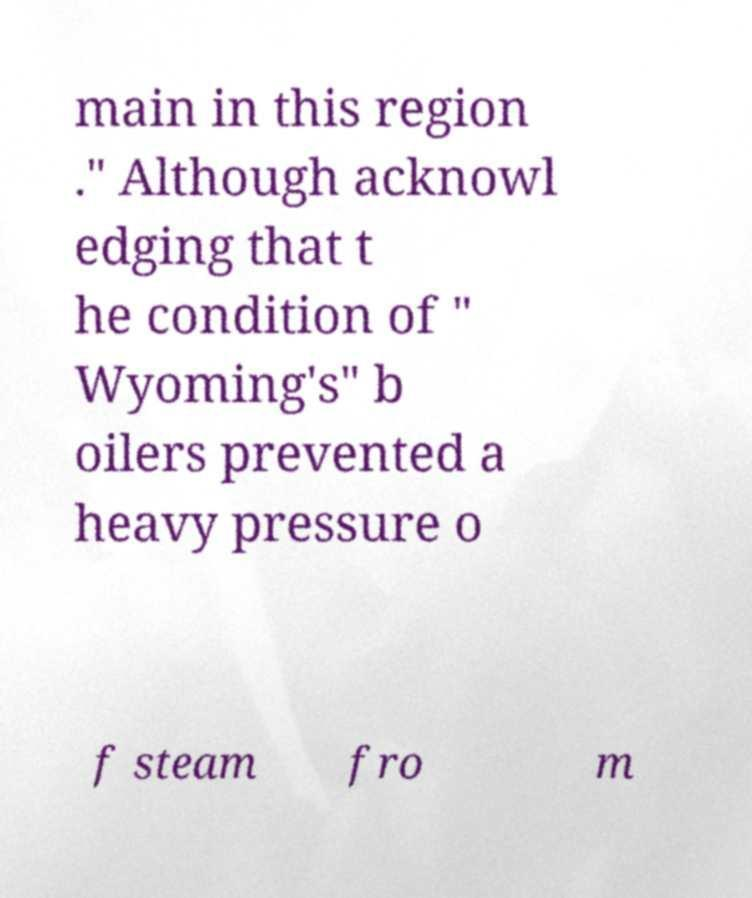I need the written content from this picture converted into text. Can you do that? main in this region ." Although acknowl edging that t he condition of " Wyoming's" b oilers prevented a heavy pressure o f steam fro m 